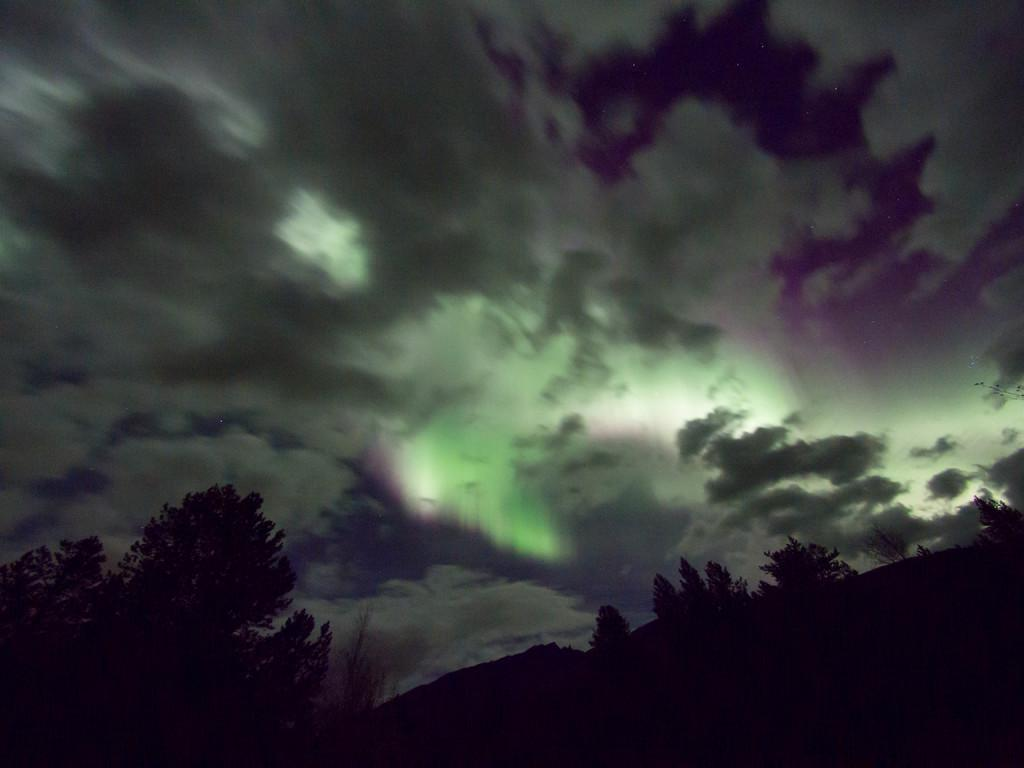What type of vegetation is present at the bottom of the image? There are trees at the bottom of the image. How would you describe the lighting at the bottom of the image? The view at the bottom is dark. What can be seen in the background of the image? The background of the image includes a cloudy sky. What is the title of the development project depicted in the image? There is no development project or title mentioned in the image. What type of board is visible in the image? There is no board present in the image. 